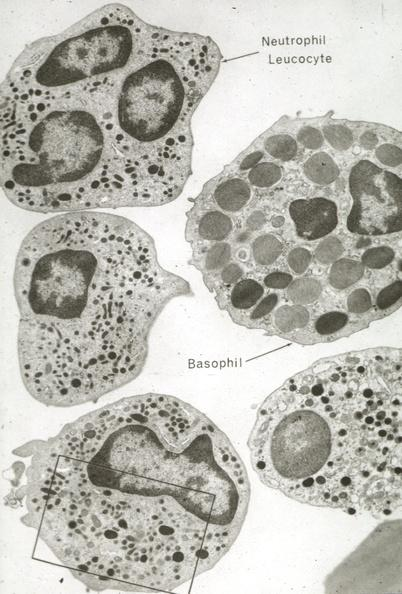s leukocytes present?
Answer the question using a single word or phrase. Yes 